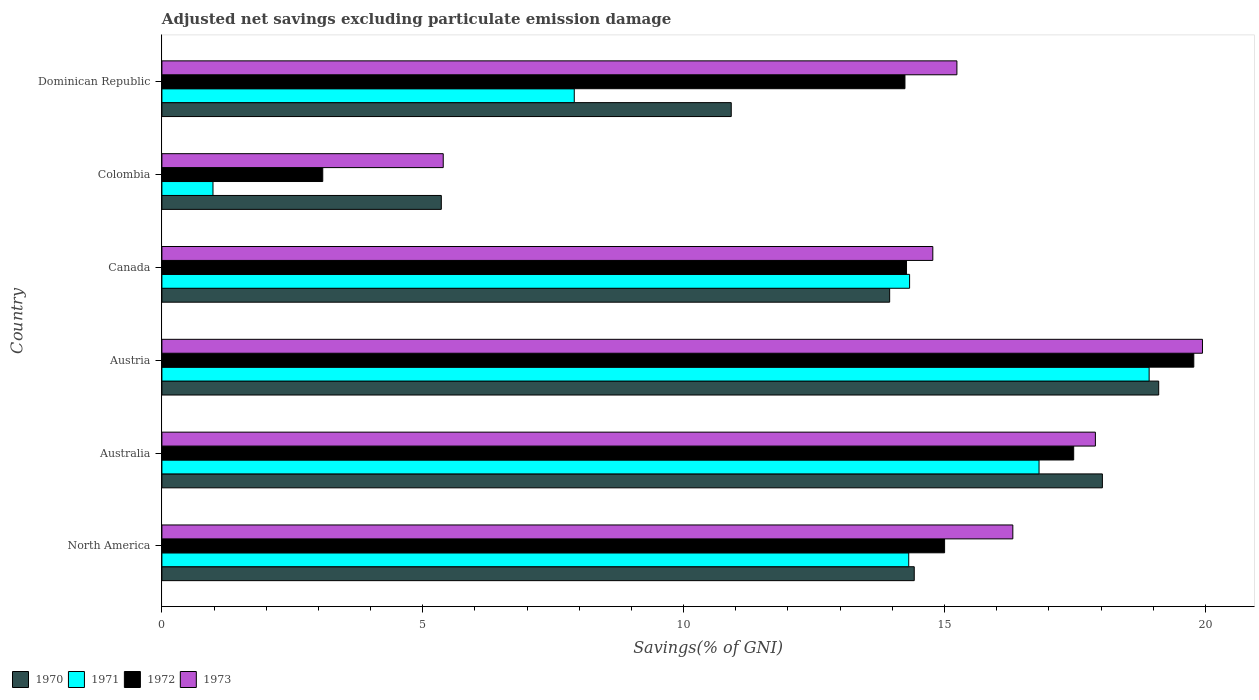How many different coloured bars are there?
Keep it short and to the point. 4. How many groups of bars are there?
Make the answer very short. 6. What is the adjusted net savings in 1973 in Colombia?
Your answer should be compact. 5.39. Across all countries, what is the maximum adjusted net savings in 1971?
Make the answer very short. 18.92. Across all countries, what is the minimum adjusted net savings in 1973?
Make the answer very short. 5.39. In which country was the adjusted net savings in 1973 maximum?
Your answer should be very brief. Austria. What is the total adjusted net savings in 1972 in the graph?
Keep it short and to the point. 83.85. What is the difference between the adjusted net savings in 1973 in Austria and that in Dominican Republic?
Offer a very short reply. 4.71. What is the difference between the adjusted net savings in 1970 in Colombia and the adjusted net savings in 1971 in Canada?
Provide a short and direct response. -8.98. What is the average adjusted net savings in 1972 per country?
Provide a short and direct response. 13.98. What is the difference between the adjusted net savings in 1971 and adjusted net savings in 1972 in Colombia?
Provide a succinct answer. -2.1. What is the ratio of the adjusted net savings in 1972 in Canada to that in North America?
Your answer should be very brief. 0.95. Is the difference between the adjusted net savings in 1971 in Austria and Canada greater than the difference between the adjusted net savings in 1972 in Austria and Canada?
Provide a succinct answer. No. What is the difference between the highest and the second highest adjusted net savings in 1970?
Provide a short and direct response. 1.08. What is the difference between the highest and the lowest adjusted net savings in 1972?
Provide a short and direct response. 16.7. Is it the case that in every country, the sum of the adjusted net savings in 1973 and adjusted net savings in 1971 is greater than the sum of adjusted net savings in 1972 and adjusted net savings in 1970?
Offer a very short reply. No. What does the 3rd bar from the top in Australia represents?
Your answer should be compact. 1971. What does the 1st bar from the bottom in Dominican Republic represents?
Your answer should be compact. 1970. How many bars are there?
Your answer should be compact. 24. Are the values on the major ticks of X-axis written in scientific E-notation?
Offer a terse response. No. Does the graph contain any zero values?
Your response must be concise. No. How many legend labels are there?
Your answer should be very brief. 4. What is the title of the graph?
Provide a short and direct response. Adjusted net savings excluding particulate emission damage. What is the label or title of the X-axis?
Offer a terse response. Savings(% of GNI). What is the Savings(% of GNI) in 1970 in North America?
Make the answer very short. 14.42. What is the Savings(% of GNI) of 1971 in North America?
Your response must be concise. 14.31. What is the Savings(% of GNI) in 1972 in North America?
Provide a short and direct response. 15. What is the Savings(% of GNI) in 1973 in North America?
Ensure brevity in your answer.  16.31. What is the Savings(% of GNI) in 1970 in Australia?
Provide a succinct answer. 18.03. What is the Savings(% of GNI) in 1971 in Australia?
Give a very brief answer. 16.81. What is the Savings(% of GNI) of 1972 in Australia?
Provide a succinct answer. 17.48. What is the Savings(% of GNI) of 1973 in Australia?
Provide a short and direct response. 17.89. What is the Savings(% of GNI) of 1970 in Austria?
Offer a terse response. 19.11. What is the Savings(% of GNI) of 1971 in Austria?
Your answer should be compact. 18.92. What is the Savings(% of GNI) of 1972 in Austria?
Provide a succinct answer. 19.78. What is the Savings(% of GNI) in 1973 in Austria?
Offer a terse response. 19.94. What is the Savings(% of GNI) in 1970 in Canada?
Your response must be concise. 13.95. What is the Savings(% of GNI) of 1971 in Canada?
Give a very brief answer. 14.33. What is the Savings(% of GNI) of 1972 in Canada?
Keep it short and to the point. 14.27. What is the Savings(% of GNI) of 1973 in Canada?
Your response must be concise. 14.78. What is the Savings(% of GNI) in 1970 in Colombia?
Your answer should be very brief. 5.36. What is the Savings(% of GNI) in 1971 in Colombia?
Make the answer very short. 0.98. What is the Savings(% of GNI) of 1972 in Colombia?
Your answer should be very brief. 3.08. What is the Savings(% of GNI) in 1973 in Colombia?
Keep it short and to the point. 5.39. What is the Savings(% of GNI) in 1970 in Dominican Republic?
Ensure brevity in your answer.  10.91. What is the Savings(% of GNI) of 1971 in Dominican Republic?
Your answer should be very brief. 7.9. What is the Savings(% of GNI) in 1972 in Dominican Republic?
Ensure brevity in your answer.  14.24. What is the Savings(% of GNI) in 1973 in Dominican Republic?
Offer a very short reply. 15.24. Across all countries, what is the maximum Savings(% of GNI) in 1970?
Keep it short and to the point. 19.11. Across all countries, what is the maximum Savings(% of GNI) in 1971?
Provide a succinct answer. 18.92. Across all countries, what is the maximum Savings(% of GNI) of 1972?
Your response must be concise. 19.78. Across all countries, what is the maximum Savings(% of GNI) of 1973?
Provide a succinct answer. 19.94. Across all countries, what is the minimum Savings(% of GNI) of 1970?
Your answer should be compact. 5.36. Across all countries, what is the minimum Savings(% of GNI) of 1971?
Your response must be concise. 0.98. Across all countries, what is the minimum Savings(% of GNI) in 1972?
Provide a short and direct response. 3.08. Across all countries, what is the minimum Savings(% of GNI) of 1973?
Your answer should be very brief. 5.39. What is the total Savings(% of GNI) of 1970 in the graph?
Your answer should be compact. 81.77. What is the total Savings(% of GNI) of 1971 in the graph?
Offer a terse response. 73.26. What is the total Savings(% of GNI) of 1972 in the graph?
Keep it short and to the point. 83.85. What is the total Savings(% of GNI) of 1973 in the graph?
Keep it short and to the point. 89.55. What is the difference between the Savings(% of GNI) in 1970 in North America and that in Australia?
Offer a very short reply. -3.61. What is the difference between the Savings(% of GNI) in 1971 in North America and that in Australia?
Make the answer very short. -2.5. What is the difference between the Savings(% of GNI) of 1972 in North America and that in Australia?
Your answer should be compact. -2.47. What is the difference between the Savings(% of GNI) in 1973 in North America and that in Australia?
Keep it short and to the point. -1.58. What is the difference between the Savings(% of GNI) of 1970 in North America and that in Austria?
Your answer should be very brief. -4.69. What is the difference between the Savings(% of GNI) in 1971 in North America and that in Austria?
Offer a terse response. -4.61. What is the difference between the Savings(% of GNI) of 1972 in North America and that in Austria?
Offer a very short reply. -4.78. What is the difference between the Savings(% of GNI) of 1973 in North America and that in Austria?
Your answer should be compact. -3.63. What is the difference between the Savings(% of GNI) of 1970 in North America and that in Canada?
Your response must be concise. 0.47. What is the difference between the Savings(% of GNI) of 1971 in North America and that in Canada?
Offer a very short reply. -0.02. What is the difference between the Savings(% of GNI) in 1972 in North America and that in Canada?
Give a very brief answer. 0.73. What is the difference between the Savings(% of GNI) of 1973 in North America and that in Canada?
Offer a very short reply. 1.53. What is the difference between the Savings(% of GNI) in 1970 in North America and that in Colombia?
Your answer should be very brief. 9.06. What is the difference between the Savings(% of GNI) of 1971 in North America and that in Colombia?
Offer a terse response. 13.34. What is the difference between the Savings(% of GNI) of 1972 in North America and that in Colombia?
Provide a short and direct response. 11.92. What is the difference between the Savings(% of GNI) in 1973 in North America and that in Colombia?
Your response must be concise. 10.92. What is the difference between the Savings(% of GNI) in 1970 in North America and that in Dominican Republic?
Offer a terse response. 3.51. What is the difference between the Savings(% of GNI) in 1971 in North America and that in Dominican Republic?
Your answer should be very brief. 6.41. What is the difference between the Savings(% of GNI) of 1972 in North America and that in Dominican Republic?
Provide a succinct answer. 0.76. What is the difference between the Savings(% of GNI) of 1973 in North America and that in Dominican Republic?
Offer a very short reply. 1.07. What is the difference between the Savings(% of GNI) in 1970 in Australia and that in Austria?
Offer a terse response. -1.08. What is the difference between the Savings(% of GNI) in 1971 in Australia and that in Austria?
Provide a short and direct response. -2.11. What is the difference between the Savings(% of GNI) in 1972 in Australia and that in Austria?
Provide a succinct answer. -2.3. What is the difference between the Savings(% of GNI) of 1973 in Australia and that in Austria?
Your answer should be very brief. -2.05. What is the difference between the Savings(% of GNI) in 1970 in Australia and that in Canada?
Ensure brevity in your answer.  4.08. What is the difference between the Savings(% of GNI) in 1971 in Australia and that in Canada?
Ensure brevity in your answer.  2.48. What is the difference between the Savings(% of GNI) in 1972 in Australia and that in Canada?
Your answer should be compact. 3.2. What is the difference between the Savings(% of GNI) in 1973 in Australia and that in Canada?
Provide a short and direct response. 3.12. What is the difference between the Savings(% of GNI) of 1970 in Australia and that in Colombia?
Your response must be concise. 12.67. What is the difference between the Savings(% of GNI) in 1971 in Australia and that in Colombia?
Keep it short and to the point. 15.83. What is the difference between the Savings(% of GNI) of 1972 in Australia and that in Colombia?
Give a very brief answer. 14.39. What is the difference between the Savings(% of GNI) in 1970 in Australia and that in Dominican Republic?
Provide a short and direct response. 7.11. What is the difference between the Savings(% of GNI) of 1971 in Australia and that in Dominican Republic?
Your answer should be compact. 8.91. What is the difference between the Savings(% of GNI) in 1972 in Australia and that in Dominican Republic?
Provide a succinct answer. 3.23. What is the difference between the Savings(% of GNI) of 1973 in Australia and that in Dominican Republic?
Offer a terse response. 2.65. What is the difference between the Savings(% of GNI) of 1970 in Austria and that in Canada?
Ensure brevity in your answer.  5.16. What is the difference between the Savings(% of GNI) of 1971 in Austria and that in Canada?
Make the answer very short. 4.59. What is the difference between the Savings(% of GNI) of 1972 in Austria and that in Canada?
Give a very brief answer. 5.51. What is the difference between the Savings(% of GNI) of 1973 in Austria and that in Canada?
Offer a terse response. 5.17. What is the difference between the Savings(% of GNI) of 1970 in Austria and that in Colombia?
Your answer should be compact. 13.75. What is the difference between the Savings(% of GNI) of 1971 in Austria and that in Colombia?
Offer a terse response. 17.94. What is the difference between the Savings(% of GNI) of 1972 in Austria and that in Colombia?
Your answer should be very brief. 16.7. What is the difference between the Savings(% of GNI) of 1973 in Austria and that in Colombia?
Offer a terse response. 14.55. What is the difference between the Savings(% of GNI) in 1970 in Austria and that in Dominican Republic?
Make the answer very short. 8.19. What is the difference between the Savings(% of GNI) in 1971 in Austria and that in Dominican Republic?
Ensure brevity in your answer.  11.02. What is the difference between the Savings(% of GNI) in 1972 in Austria and that in Dominican Republic?
Provide a short and direct response. 5.54. What is the difference between the Savings(% of GNI) in 1973 in Austria and that in Dominican Republic?
Provide a short and direct response. 4.71. What is the difference between the Savings(% of GNI) of 1970 in Canada and that in Colombia?
Make the answer very short. 8.59. What is the difference between the Savings(% of GNI) of 1971 in Canada and that in Colombia?
Your answer should be very brief. 13.35. What is the difference between the Savings(% of GNI) of 1972 in Canada and that in Colombia?
Your answer should be very brief. 11.19. What is the difference between the Savings(% of GNI) in 1973 in Canada and that in Colombia?
Give a very brief answer. 9.38. What is the difference between the Savings(% of GNI) of 1970 in Canada and that in Dominican Republic?
Your answer should be very brief. 3.04. What is the difference between the Savings(% of GNI) of 1971 in Canada and that in Dominican Republic?
Make the answer very short. 6.43. What is the difference between the Savings(% of GNI) of 1972 in Canada and that in Dominican Republic?
Provide a short and direct response. 0.03. What is the difference between the Savings(% of GNI) of 1973 in Canada and that in Dominican Republic?
Provide a short and direct response. -0.46. What is the difference between the Savings(% of GNI) in 1970 in Colombia and that in Dominican Republic?
Make the answer very short. -5.56. What is the difference between the Savings(% of GNI) of 1971 in Colombia and that in Dominican Republic?
Keep it short and to the point. -6.92. What is the difference between the Savings(% of GNI) in 1972 in Colombia and that in Dominican Republic?
Make the answer very short. -11.16. What is the difference between the Savings(% of GNI) of 1973 in Colombia and that in Dominican Republic?
Keep it short and to the point. -9.85. What is the difference between the Savings(% of GNI) in 1970 in North America and the Savings(% of GNI) in 1971 in Australia?
Give a very brief answer. -2.39. What is the difference between the Savings(% of GNI) of 1970 in North America and the Savings(% of GNI) of 1972 in Australia?
Provide a short and direct response. -3.06. What is the difference between the Savings(% of GNI) in 1970 in North America and the Savings(% of GNI) in 1973 in Australia?
Ensure brevity in your answer.  -3.47. What is the difference between the Savings(% of GNI) in 1971 in North America and the Savings(% of GNI) in 1972 in Australia?
Provide a succinct answer. -3.16. What is the difference between the Savings(% of GNI) in 1971 in North America and the Savings(% of GNI) in 1973 in Australia?
Provide a short and direct response. -3.58. What is the difference between the Savings(% of GNI) in 1972 in North America and the Savings(% of GNI) in 1973 in Australia?
Your answer should be very brief. -2.89. What is the difference between the Savings(% of GNI) in 1970 in North America and the Savings(% of GNI) in 1971 in Austria?
Offer a very short reply. -4.5. What is the difference between the Savings(% of GNI) of 1970 in North America and the Savings(% of GNI) of 1972 in Austria?
Provide a short and direct response. -5.36. What is the difference between the Savings(% of GNI) in 1970 in North America and the Savings(% of GNI) in 1973 in Austria?
Offer a very short reply. -5.52. What is the difference between the Savings(% of GNI) of 1971 in North America and the Savings(% of GNI) of 1972 in Austria?
Your answer should be very brief. -5.46. What is the difference between the Savings(% of GNI) of 1971 in North America and the Savings(% of GNI) of 1973 in Austria?
Your response must be concise. -5.63. What is the difference between the Savings(% of GNI) in 1972 in North America and the Savings(% of GNI) in 1973 in Austria?
Provide a short and direct response. -4.94. What is the difference between the Savings(% of GNI) of 1970 in North America and the Savings(% of GNI) of 1971 in Canada?
Offer a very short reply. 0.09. What is the difference between the Savings(% of GNI) of 1970 in North America and the Savings(% of GNI) of 1972 in Canada?
Your answer should be very brief. 0.15. What is the difference between the Savings(% of GNI) in 1970 in North America and the Savings(% of GNI) in 1973 in Canada?
Your answer should be very brief. -0.36. What is the difference between the Savings(% of GNI) in 1971 in North America and the Savings(% of GNI) in 1972 in Canada?
Offer a very short reply. 0.04. What is the difference between the Savings(% of GNI) of 1971 in North America and the Savings(% of GNI) of 1973 in Canada?
Your response must be concise. -0.46. What is the difference between the Savings(% of GNI) of 1972 in North America and the Savings(% of GNI) of 1973 in Canada?
Your answer should be compact. 0.23. What is the difference between the Savings(% of GNI) in 1970 in North America and the Savings(% of GNI) in 1971 in Colombia?
Provide a short and direct response. 13.44. What is the difference between the Savings(% of GNI) of 1970 in North America and the Savings(% of GNI) of 1972 in Colombia?
Your answer should be very brief. 11.34. What is the difference between the Savings(% of GNI) of 1970 in North America and the Savings(% of GNI) of 1973 in Colombia?
Give a very brief answer. 9.03. What is the difference between the Savings(% of GNI) of 1971 in North America and the Savings(% of GNI) of 1972 in Colombia?
Keep it short and to the point. 11.23. What is the difference between the Savings(% of GNI) in 1971 in North America and the Savings(% of GNI) in 1973 in Colombia?
Provide a short and direct response. 8.92. What is the difference between the Savings(% of GNI) in 1972 in North America and the Savings(% of GNI) in 1973 in Colombia?
Provide a short and direct response. 9.61. What is the difference between the Savings(% of GNI) in 1970 in North America and the Savings(% of GNI) in 1971 in Dominican Republic?
Give a very brief answer. 6.52. What is the difference between the Savings(% of GNI) of 1970 in North America and the Savings(% of GNI) of 1972 in Dominican Republic?
Your answer should be compact. 0.18. What is the difference between the Savings(% of GNI) in 1970 in North America and the Savings(% of GNI) in 1973 in Dominican Republic?
Your response must be concise. -0.82. What is the difference between the Savings(% of GNI) in 1971 in North America and the Savings(% of GNI) in 1972 in Dominican Republic?
Offer a very short reply. 0.07. What is the difference between the Savings(% of GNI) of 1971 in North America and the Savings(% of GNI) of 1973 in Dominican Republic?
Offer a terse response. -0.92. What is the difference between the Savings(% of GNI) of 1972 in North America and the Savings(% of GNI) of 1973 in Dominican Republic?
Your answer should be compact. -0.24. What is the difference between the Savings(% of GNI) of 1970 in Australia and the Savings(% of GNI) of 1971 in Austria?
Offer a very short reply. -0.9. What is the difference between the Savings(% of GNI) of 1970 in Australia and the Savings(% of GNI) of 1972 in Austria?
Offer a terse response. -1.75. What is the difference between the Savings(% of GNI) in 1970 in Australia and the Savings(% of GNI) in 1973 in Austria?
Your answer should be very brief. -1.92. What is the difference between the Savings(% of GNI) in 1971 in Australia and the Savings(% of GNI) in 1972 in Austria?
Offer a terse response. -2.97. What is the difference between the Savings(% of GNI) of 1971 in Australia and the Savings(% of GNI) of 1973 in Austria?
Offer a very short reply. -3.13. What is the difference between the Savings(% of GNI) of 1972 in Australia and the Savings(% of GNI) of 1973 in Austria?
Offer a very short reply. -2.47. What is the difference between the Savings(% of GNI) in 1970 in Australia and the Savings(% of GNI) in 1971 in Canada?
Offer a terse response. 3.7. What is the difference between the Savings(% of GNI) of 1970 in Australia and the Savings(% of GNI) of 1972 in Canada?
Your answer should be very brief. 3.75. What is the difference between the Savings(% of GNI) in 1970 in Australia and the Savings(% of GNI) in 1973 in Canada?
Your response must be concise. 3.25. What is the difference between the Savings(% of GNI) of 1971 in Australia and the Savings(% of GNI) of 1972 in Canada?
Your response must be concise. 2.54. What is the difference between the Savings(% of GNI) in 1971 in Australia and the Savings(% of GNI) in 1973 in Canada?
Offer a very short reply. 2.04. What is the difference between the Savings(% of GNI) in 1972 in Australia and the Savings(% of GNI) in 1973 in Canada?
Keep it short and to the point. 2.7. What is the difference between the Savings(% of GNI) of 1970 in Australia and the Savings(% of GNI) of 1971 in Colombia?
Offer a terse response. 17.05. What is the difference between the Savings(% of GNI) of 1970 in Australia and the Savings(% of GNI) of 1972 in Colombia?
Provide a succinct answer. 14.94. What is the difference between the Savings(% of GNI) in 1970 in Australia and the Savings(% of GNI) in 1973 in Colombia?
Provide a succinct answer. 12.63. What is the difference between the Savings(% of GNI) in 1971 in Australia and the Savings(% of GNI) in 1972 in Colombia?
Keep it short and to the point. 13.73. What is the difference between the Savings(% of GNI) in 1971 in Australia and the Savings(% of GNI) in 1973 in Colombia?
Make the answer very short. 11.42. What is the difference between the Savings(% of GNI) of 1972 in Australia and the Savings(% of GNI) of 1973 in Colombia?
Provide a succinct answer. 12.08. What is the difference between the Savings(% of GNI) in 1970 in Australia and the Savings(% of GNI) in 1971 in Dominican Republic?
Offer a terse response. 10.12. What is the difference between the Savings(% of GNI) of 1970 in Australia and the Savings(% of GNI) of 1972 in Dominican Republic?
Offer a very short reply. 3.78. What is the difference between the Savings(% of GNI) of 1970 in Australia and the Savings(% of GNI) of 1973 in Dominican Republic?
Give a very brief answer. 2.79. What is the difference between the Savings(% of GNI) of 1971 in Australia and the Savings(% of GNI) of 1972 in Dominican Republic?
Give a very brief answer. 2.57. What is the difference between the Savings(% of GNI) in 1971 in Australia and the Savings(% of GNI) in 1973 in Dominican Republic?
Provide a succinct answer. 1.57. What is the difference between the Savings(% of GNI) of 1972 in Australia and the Savings(% of GNI) of 1973 in Dominican Republic?
Offer a very short reply. 2.24. What is the difference between the Savings(% of GNI) in 1970 in Austria and the Savings(% of GNI) in 1971 in Canada?
Provide a short and direct response. 4.77. What is the difference between the Savings(% of GNI) in 1970 in Austria and the Savings(% of GNI) in 1972 in Canada?
Make the answer very short. 4.83. What is the difference between the Savings(% of GNI) in 1970 in Austria and the Savings(% of GNI) in 1973 in Canada?
Give a very brief answer. 4.33. What is the difference between the Savings(% of GNI) of 1971 in Austria and the Savings(% of GNI) of 1972 in Canada?
Your answer should be compact. 4.65. What is the difference between the Savings(% of GNI) of 1971 in Austria and the Savings(% of GNI) of 1973 in Canada?
Make the answer very short. 4.15. What is the difference between the Savings(% of GNI) in 1972 in Austria and the Savings(% of GNI) in 1973 in Canada?
Keep it short and to the point. 5. What is the difference between the Savings(% of GNI) of 1970 in Austria and the Savings(% of GNI) of 1971 in Colombia?
Keep it short and to the point. 18.13. What is the difference between the Savings(% of GNI) in 1970 in Austria and the Savings(% of GNI) in 1972 in Colombia?
Give a very brief answer. 16.02. What is the difference between the Savings(% of GNI) of 1970 in Austria and the Savings(% of GNI) of 1973 in Colombia?
Make the answer very short. 13.71. What is the difference between the Savings(% of GNI) of 1971 in Austria and the Savings(% of GNI) of 1972 in Colombia?
Keep it short and to the point. 15.84. What is the difference between the Savings(% of GNI) of 1971 in Austria and the Savings(% of GNI) of 1973 in Colombia?
Your answer should be very brief. 13.53. What is the difference between the Savings(% of GNI) in 1972 in Austria and the Savings(% of GNI) in 1973 in Colombia?
Keep it short and to the point. 14.39. What is the difference between the Savings(% of GNI) of 1970 in Austria and the Savings(% of GNI) of 1971 in Dominican Republic?
Your answer should be very brief. 11.2. What is the difference between the Savings(% of GNI) of 1970 in Austria and the Savings(% of GNI) of 1972 in Dominican Republic?
Keep it short and to the point. 4.86. What is the difference between the Savings(% of GNI) of 1970 in Austria and the Savings(% of GNI) of 1973 in Dominican Republic?
Ensure brevity in your answer.  3.87. What is the difference between the Savings(% of GNI) in 1971 in Austria and the Savings(% of GNI) in 1972 in Dominican Republic?
Your answer should be compact. 4.68. What is the difference between the Savings(% of GNI) of 1971 in Austria and the Savings(% of GNI) of 1973 in Dominican Republic?
Provide a succinct answer. 3.68. What is the difference between the Savings(% of GNI) of 1972 in Austria and the Savings(% of GNI) of 1973 in Dominican Republic?
Ensure brevity in your answer.  4.54. What is the difference between the Savings(% of GNI) in 1970 in Canada and the Savings(% of GNI) in 1971 in Colombia?
Offer a very short reply. 12.97. What is the difference between the Savings(% of GNI) of 1970 in Canada and the Savings(% of GNI) of 1972 in Colombia?
Make the answer very short. 10.87. What is the difference between the Savings(% of GNI) in 1970 in Canada and the Savings(% of GNI) in 1973 in Colombia?
Keep it short and to the point. 8.56. What is the difference between the Savings(% of GNI) in 1971 in Canada and the Savings(% of GNI) in 1972 in Colombia?
Offer a terse response. 11.25. What is the difference between the Savings(% of GNI) in 1971 in Canada and the Savings(% of GNI) in 1973 in Colombia?
Offer a terse response. 8.94. What is the difference between the Savings(% of GNI) in 1972 in Canada and the Savings(% of GNI) in 1973 in Colombia?
Make the answer very short. 8.88. What is the difference between the Savings(% of GNI) in 1970 in Canada and the Savings(% of GNI) in 1971 in Dominican Republic?
Your answer should be compact. 6.05. What is the difference between the Savings(% of GNI) in 1970 in Canada and the Savings(% of GNI) in 1972 in Dominican Republic?
Ensure brevity in your answer.  -0.29. What is the difference between the Savings(% of GNI) in 1970 in Canada and the Savings(% of GNI) in 1973 in Dominican Republic?
Offer a very short reply. -1.29. What is the difference between the Savings(% of GNI) in 1971 in Canada and the Savings(% of GNI) in 1972 in Dominican Republic?
Ensure brevity in your answer.  0.09. What is the difference between the Savings(% of GNI) of 1971 in Canada and the Savings(% of GNI) of 1973 in Dominican Republic?
Your answer should be compact. -0.91. What is the difference between the Savings(% of GNI) of 1972 in Canada and the Savings(% of GNI) of 1973 in Dominican Republic?
Provide a short and direct response. -0.97. What is the difference between the Savings(% of GNI) in 1970 in Colombia and the Savings(% of GNI) in 1971 in Dominican Republic?
Ensure brevity in your answer.  -2.55. What is the difference between the Savings(% of GNI) of 1970 in Colombia and the Savings(% of GNI) of 1972 in Dominican Republic?
Your response must be concise. -8.89. What is the difference between the Savings(% of GNI) of 1970 in Colombia and the Savings(% of GNI) of 1973 in Dominican Republic?
Provide a short and direct response. -9.88. What is the difference between the Savings(% of GNI) of 1971 in Colombia and the Savings(% of GNI) of 1972 in Dominican Republic?
Offer a very short reply. -13.26. What is the difference between the Savings(% of GNI) in 1971 in Colombia and the Savings(% of GNI) in 1973 in Dominican Republic?
Offer a terse response. -14.26. What is the difference between the Savings(% of GNI) in 1972 in Colombia and the Savings(% of GNI) in 1973 in Dominican Republic?
Provide a succinct answer. -12.15. What is the average Savings(% of GNI) in 1970 per country?
Ensure brevity in your answer.  13.63. What is the average Savings(% of GNI) of 1971 per country?
Make the answer very short. 12.21. What is the average Savings(% of GNI) in 1972 per country?
Keep it short and to the point. 13.98. What is the average Savings(% of GNI) in 1973 per country?
Provide a succinct answer. 14.93. What is the difference between the Savings(% of GNI) in 1970 and Savings(% of GNI) in 1971 in North America?
Your answer should be compact. 0.11. What is the difference between the Savings(% of GNI) of 1970 and Savings(% of GNI) of 1972 in North America?
Give a very brief answer. -0.58. What is the difference between the Savings(% of GNI) in 1970 and Savings(% of GNI) in 1973 in North America?
Offer a very short reply. -1.89. What is the difference between the Savings(% of GNI) in 1971 and Savings(% of GNI) in 1972 in North America?
Provide a succinct answer. -0.69. What is the difference between the Savings(% of GNI) of 1971 and Savings(% of GNI) of 1973 in North America?
Provide a short and direct response. -2. What is the difference between the Savings(% of GNI) in 1972 and Savings(% of GNI) in 1973 in North America?
Your response must be concise. -1.31. What is the difference between the Savings(% of GNI) of 1970 and Savings(% of GNI) of 1971 in Australia?
Offer a very short reply. 1.21. What is the difference between the Savings(% of GNI) of 1970 and Savings(% of GNI) of 1972 in Australia?
Offer a terse response. 0.55. What is the difference between the Savings(% of GNI) of 1970 and Savings(% of GNI) of 1973 in Australia?
Ensure brevity in your answer.  0.13. What is the difference between the Savings(% of GNI) in 1971 and Savings(% of GNI) in 1972 in Australia?
Give a very brief answer. -0.66. What is the difference between the Savings(% of GNI) of 1971 and Savings(% of GNI) of 1973 in Australia?
Your answer should be very brief. -1.08. What is the difference between the Savings(% of GNI) of 1972 and Savings(% of GNI) of 1973 in Australia?
Provide a short and direct response. -0.42. What is the difference between the Savings(% of GNI) of 1970 and Savings(% of GNI) of 1971 in Austria?
Give a very brief answer. 0.18. What is the difference between the Savings(% of GNI) of 1970 and Savings(% of GNI) of 1972 in Austria?
Provide a short and direct response. -0.67. What is the difference between the Savings(% of GNI) in 1970 and Savings(% of GNI) in 1973 in Austria?
Offer a very short reply. -0.84. What is the difference between the Savings(% of GNI) in 1971 and Savings(% of GNI) in 1972 in Austria?
Offer a terse response. -0.86. What is the difference between the Savings(% of GNI) of 1971 and Savings(% of GNI) of 1973 in Austria?
Your response must be concise. -1.02. What is the difference between the Savings(% of GNI) of 1972 and Savings(% of GNI) of 1973 in Austria?
Make the answer very short. -0.17. What is the difference between the Savings(% of GNI) of 1970 and Savings(% of GNI) of 1971 in Canada?
Your answer should be compact. -0.38. What is the difference between the Savings(% of GNI) in 1970 and Savings(% of GNI) in 1972 in Canada?
Your answer should be very brief. -0.32. What is the difference between the Savings(% of GNI) of 1970 and Savings(% of GNI) of 1973 in Canada?
Offer a terse response. -0.83. What is the difference between the Savings(% of GNI) in 1971 and Savings(% of GNI) in 1972 in Canada?
Your response must be concise. 0.06. What is the difference between the Savings(% of GNI) in 1971 and Savings(% of GNI) in 1973 in Canada?
Offer a very short reply. -0.45. What is the difference between the Savings(% of GNI) of 1972 and Savings(% of GNI) of 1973 in Canada?
Give a very brief answer. -0.5. What is the difference between the Savings(% of GNI) of 1970 and Savings(% of GNI) of 1971 in Colombia?
Your response must be concise. 4.38. What is the difference between the Savings(% of GNI) in 1970 and Savings(% of GNI) in 1972 in Colombia?
Ensure brevity in your answer.  2.27. What is the difference between the Savings(% of GNI) in 1970 and Savings(% of GNI) in 1973 in Colombia?
Give a very brief answer. -0.04. What is the difference between the Savings(% of GNI) of 1971 and Savings(% of GNI) of 1972 in Colombia?
Your answer should be very brief. -2.1. What is the difference between the Savings(% of GNI) in 1971 and Savings(% of GNI) in 1973 in Colombia?
Offer a very short reply. -4.41. What is the difference between the Savings(% of GNI) in 1972 and Savings(% of GNI) in 1973 in Colombia?
Your answer should be compact. -2.31. What is the difference between the Savings(% of GNI) of 1970 and Savings(% of GNI) of 1971 in Dominican Republic?
Provide a short and direct response. 3.01. What is the difference between the Savings(% of GNI) in 1970 and Savings(% of GNI) in 1972 in Dominican Republic?
Provide a short and direct response. -3.33. What is the difference between the Savings(% of GNI) of 1970 and Savings(% of GNI) of 1973 in Dominican Republic?
Offer a terse response. -4.33. What is the difference between the Savings(% of GNI) of 1971 and Savings(% of GNI) of 1972 in Dominican Republic?
Your response must be concise. -6.34. What is the difference between the Savings(% of GNI) of 1971 and Savings(% of GNI) of 1973 in Dominican Republic?
Offer a terse response. -7.33. What is the difference between the Savings(% of GNI) of 1972 and Savings(% of GNI) of 1973 in Dominican Republic?
Your answer should be compact. -1. What is the ratio of the Savings(% of GNI) in 1970 in North America to that in Australia?
Make the answer very short. 0.8. What is the ratio of the Savings(% of GNI) of 1971 in North America to that in Australia?
Keep it short and to the point. 0.85. What is the ratio of the Savings(% of GNI) in 1972 in North America to that in Australia?
Ensure brevity in your answer.  0.86. What is the ratio of the Savings(% of GNI) in 1973 in North America to that in Australia?
Keep it short and to the point. 0.91. What is the ratio of the Savings(% of GNI) in 1970 in North America to that in Austria?
Your answer should be very brief. 0.75. What is the ratio of the Savings(% of GNI) of 1971 in North America to that in Austria?
Provide a short and direct response. 0.76. What is the ratio of the Savings(% of GNI) of 1972 in North America to that in Austria?
Provide a short and direct response. 0.76. What is the ratio of the Savings(% of GNI) in 1973 in North America to that in Austria?
Your response must be concise. 0.82. What is the ratio of the Savings(% of GNI) in 1970 in North America to that in Canada?
Your answer should be compact. 1.03. What is the ratio of the Savings(% of GNI) of 1972 in North America to that in Canada?
Your response must be concise. 1.05. What is the ratio of the Savings(% of GNI) in 1973 in North America to that in Canada?
Offer a very short reply. 1.1. What is the ratio of the Savings(% of GNI) of 1970 in North America to that in Colombia?
Give a very brief answer. 2.69. What is the ratio of the Savings(% of GNI) in 1971 in North America to that in Colombia?
Provide a succinct answer. 14.62. What is the ratio of the Savings(% of GNI) in 1972 in North America to that in Colombia?
Keep it short and to the point. 4.87. What is the ratio of the Savings(% of GNI) in 1973 in North America to that in Colombia?
Make the answer very short. 3.02. What is the ratio of the Savings(% of GNI) in 1970 in North America to that in Dominican Republic?
Make the answer very short. 1.32. What is the ratio of the Savings(% of GNI) in 1971 in North America to that in Dominican Republic?
Your response must be concise. 1.81. What is the ratio of the Savings(% of GNI) of 1972 in North America to that in Dominican Republic?
Keep it short and to the point. 1.05. What is the ratio of the Savings(% of GNI) in 1973 in North America to that in Dominican Republic?
Offer a very short reply. 1.07. What is the ratio of the Savings(% of GNI) in 1970 in Australia to that in Austria?
Your answer should be very brief. 0.94. What is the ratio of the Savings(% of GNI) in 1971 in Australia to that in Austria?
Keep it short and to the point. 0.89. What is the ratio of the Savings(% of GNI) of 1972 in Australia to that in Austria?
Make the answer very short. 0.88. What is the ratio of the Savings(% of GNI) in 1973 in Australia to that in Austria?
Offer a terse response. 0.9. What is the ratio of the Savings(% of GNI) in 1970 in Australia to that in Canada?
Offer a very short reply. 1.29. What is the ratio of the Savings(% of GNI) of 1971 in Australia to that in Canada?
Provide a succinct answer. 1.17. What is the ratio of the Savings(% of GNI) in 1972 in Australia to that in Canada?
Your answer should be very brief. 1.22. What is the ratio of the Savings(% of GNI) of 1973 in Australia to that in Canada?
Provide a short and direct response. 1.21. What is the ratio of the Savings(% of GNI) of 1970 in Australia to that in Colombia?
Make the answer very short. 3.37. What is the ratio of the Savings(% of GNI) of 1971 in Australia to that in Colombia?
Ensure brevity in your answer.  17.17. What is the ratio of the Savings(% of GNI) of 1972 in Australia to that in Colombia?
Give a very brief answer. 5.67. What is the ratio of the Savings(% of GNI) in 1973 in Australia to that in Colombia?
Keep it short and to the point. 3.32. What is the ratio of the Savings(% of GNI) of 1970 in Australia to that in Dominican Republic?
Provide a succinct answer. 1.65. What is the ratio of the Savings(% of GNI) in 1971 in Australia to that in Dominican Republic?
Make the answer very short. 2.13. What is the ratio of the Savings(% of GNI) of 1972 in Australia to that in Dominican Republic?
Make the answer very short. 1.23. What is the ratio of the Savings(% of GNI) of 1973 in Australia to that in Dominican Republic?
Offer a terse response. 1.17. What is the ratio of the Savings(% of GNI) in 1970 in Austria to that in Canada?
Provide a succinct answer. 1.37. What is the ratio of the Savings(% of GNI) of 1971 in Austria to that in Canada?
Ensure brevity in your answer.  1.32. What is the ratio of the Savings(% of GNI) of 1972 in Austria to that in Canada?
Provide a succinct answer. 1.39. What is the ratio of the Savings(% of GNI) of 1973 in Austria to that in Canada?
Your answer should be very brief. 1.35. What is the ratio of the Savings(% of GNI) in 1970 in Austria to that in Colombia?
Make the answer very short. 3.57. What is the ratio of the Savings(% of GNI) in 1971 in Austria to that in Colombia?
Provide a short and direct response. 19.32. What is the ratio of the Savings(% of GNI) of 1972 in Austria to that in Colombia?
Provide a short and direct response. 6.42. What is the ratio of the Savings(% of GNI) in 1973 in Austria to that in Colombia?
Offer a terse response. 3.7. What is the ratio of the Savings(% of GNI) of 1970 in Austria to that in Dominican Republic?
Provide a short and direct response. 1.75. What is the ratio of the Savings(% of GNI) of 1971 in Austria to that in Dominican Republic?
Give a very brief answer. 2.39. What is the ratio of the Savings(% of GNI) in 1972 in Austria to that in Dominican Republic?
Provide a succinct answer. 1.39. What is the ratio of the Savings(% of GNI) of 1973 in Austria to that in Dominican Republic?
Offer a terse response. 1.31. What is the ratio of the Savings(% of GNI) in 1970 in Canada to that in Colombia?
Your response must be concise. 2.6. What is the ratio of the Savings(% of GNI) of 1971 in Canada to that in Colombia?
Offer a very short reply. 14.64. What is the ratio of the Savings(% of GNI) in 1972 in Canada to that in Colombia?
Your answer should be very brief. 4.63. What is the ratio of the Savings(% of GNI) in 1973 in Canada to that in Colombia?
Keep it short and to the point. 2.74. What is the ratio of the Savings(% of GNI) of 1970 in Canada to that in Dominican Republic?
Your response must be concise. 1.28. What is the ratio of the Savings(% of GNI) of 1971 in Canada to that in Dominican Republic?
Offer a very short reply. 1.81. What is the ratio of the Savings(% of GNI) in 1973 in Canada to that in Dominican Republic?
Provide a succinct answer. 0.97. What is the ratio of the Savings(% of GNI) in 1970 in Colombia to that in Dominican Republic?
Offer a terse response. 0.49. What is the ratio of the Savings(% of GNI) in 1971 in Colombia to that in Dominican Republic?
Your answer should be very brief. 0.12. What is the ratio of the Savings(% of GNI) in 1972 in Colombia to that in Dominican Republic?
Your answer should be very brief. 0.22. What is the ratio of the Savings(% of GNI) in 1973 in Colombia to that in Dominican Republic?
Ensure brevity in your answer.  0.35. What is the difference between the highest and the second highest Savings(% of GNI) of 1970?
Make the answer very short. 1.08. What is the difference between the highest and the second highest Savings(% of GNI) in 1971?
Provide a short and direct response. 2.11. What is the difference between the highest and the second highest Savings(% of GNI) in 1972?
Your answer should be compact. 2.3. What is the difference between the highest and the second highest Savings(% of GNI) of 1973?
Provide a succinct answer. 2.05. What is the difference between the highest and the lowest Savings(% of GNI) of 1970?
Provide a short and direct response. 13.75. What is the difference between the highest and the lowest Savings(% of GNI) in 1971?
Your response must be concise. 17.94. What is the difference between the highest and the lowest Savings(% of GNI) of 1972?
Your answer should be very brief. 16.7. What is the difference between the highest and the lowest Savings(% of GNI) of 1973?
Your answer should be very brief. 14.55. 